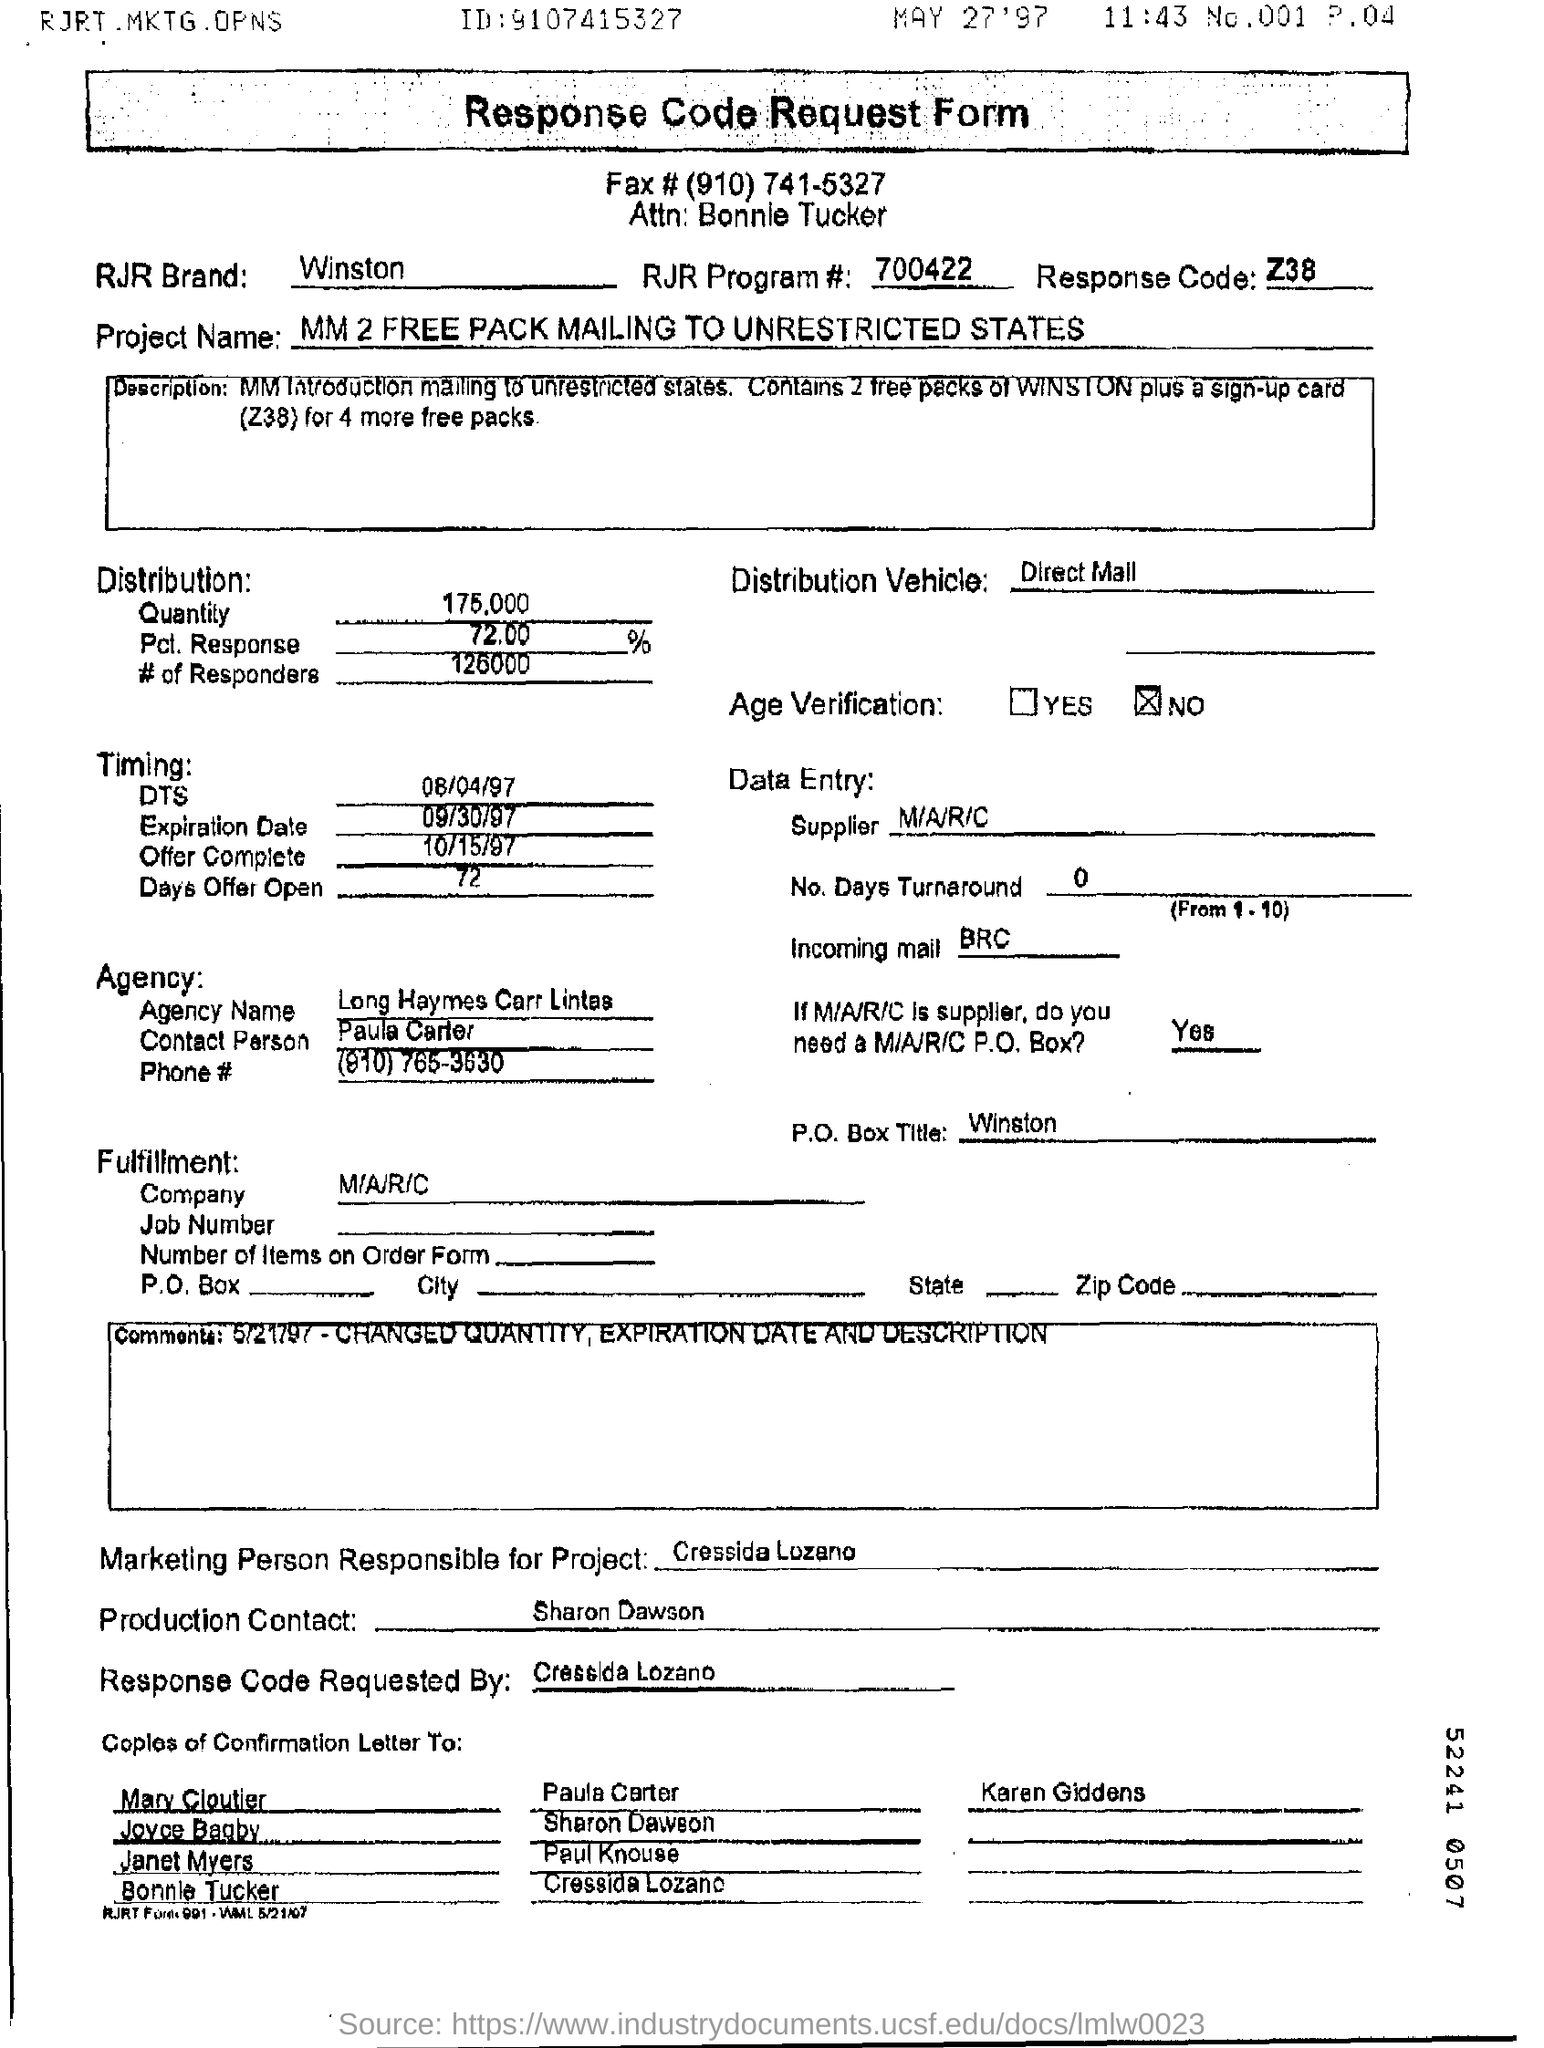What is the RJR Program# mentioned in the form?
Your response must be concise. 700422. Who is the marketing person responsible for this project ?
Offer a very short reply. Cressida Lozano. What is the Response code ?
Keep it short and to the point. Z38. What is the Quantity of the Distribution ?
Provide a short and direct response. 175,000. 